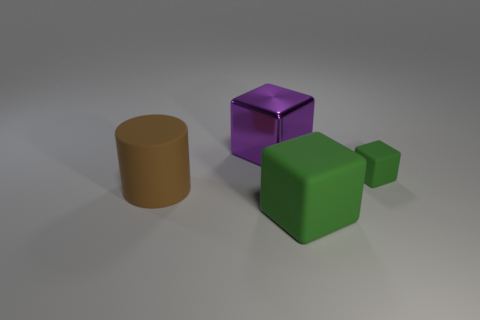Subtract all blue cylinders. Subtract all gray cubes. How many cylinders are left? 1 Subtract all purple blocks. How many cyan cylinders are left? 0 Add 4 tiny objects. How many greens exist? 0 Subtract all big green cylinders. Subtract all small matte cubes. How many objects are left? 3 Add 3 green matte blocks. How many green matte blocks are left? 5 Add 3 tiny rubber cylinders. How many tiny rubber cylinders exist? 3 Add 1 large blue metal spheres. How many objects exist? 5 Subtract all purple cubes. How many cubes are left? 2 Subtract all shiny blocks. How many blocks are left? 2 Subtract 0 yellow cylinders. How many objects are left? 4 